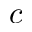<formula> <loc_0><loc_0><loc_500><loc_500>c</formula> 